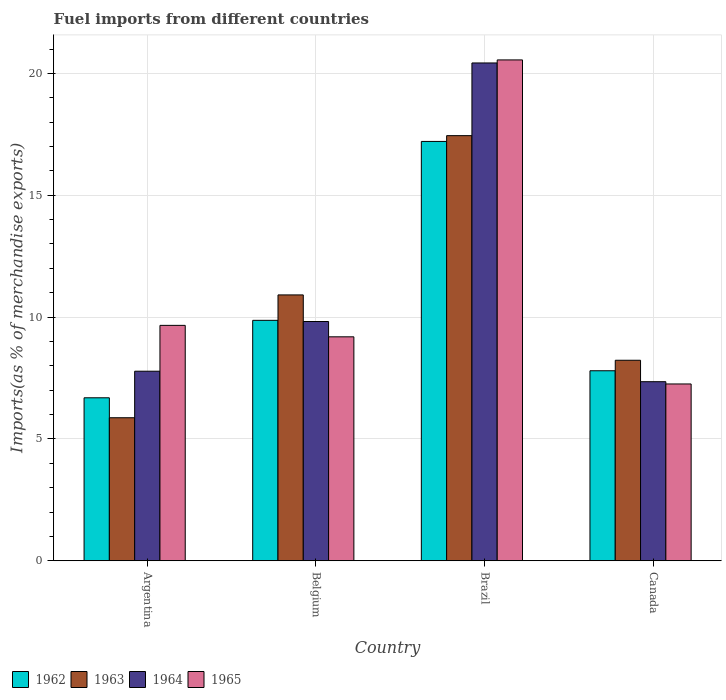How many different coloured bars are there?
Offer a terse response. 4. How many groups of bars are there?
Offer a very short reply. 4. Are the number of bars per tick equal to the number of legend labels?
Make the answer very short. Yes. Are the number of bars on each tick of the X-axis equal?
Give a very brief answer. Yes. How many bars are there on the 3rd tick from the left?
Ensure brevity in your answer.  4. What is the label of the 2nd group of bars from the left?
Your answer should be compact. Belgium. What is the percentage of imports to different countries in 1962 in Brazil?
Keep it short and to the point. 17.21. Across all countries, what is the maximum percentage of imports to different countries in 1965?
Your answer should be very brief. 20.55. Across all countries, what is the minimum percentage of imports to different countries in 1965?
Give a very brief answer. 7.26. In which country was the percentage of imports to different countries in 1964 maximum?
Ensure brevity in your answer.  Brazil. What is the total percentage of imports to different countries in 1963 in the graph?
Ensure brevity in your answer.  42.46. What is the difference between the percentage of imports to different countries in 1964 in Argentina and that in Brazil?
Your response must be concise. -12.65. What is the difference between the percentage of imports to different countries in 1964 in Canada and the percentage of imports to different countries in 1962 in Belgium?
Make the answer very short. -2.52. What is the average percentage of imports to different countries in 1964 per country?
Keep it short and to the point. 11.34. What is the difference between the percentage of imports to different countries of/in 1964 and percentage of imports to different countries of/in 1965 in Brazil?
Keep it short and to the point. -0.12. What is the ratio of the percentage of imports to different countries in 1962 in Argentina to that in Belgium?
Your response must be concise. 0.68. What is the difference between the highest and the second highest percentage of imports to different countries in 1962?
Your answer should be very brief. 7.34. What is the difference between the highest and the lowest percentage of imports to different countries in 1963?
Give a very brief answer. 11.58. Is it the case that in every country, the sum of the percentage of imports to different countries in 1965 and percentage of imports to different countries in 1962 is greater than the sum of percentage of imports to different countries in 1963 and percentage of imports to different countries in 1964?
Your response must be concise. No. What does the 1st bar from the right in Belgium represents?
Offer a very short reply. 1965. Is it the case that in every country, the sum of the percentage of imports to different countries in 1965 and percentage of imports to different countries in 1963 is greater than the percentage of imports to different countries in 1962?
Provide a short and direct response. Yes. What is the difference between two consecutive major ticks on the Y-axis?
Provide a short and direct response. 5. Does the graph contain grids?
Make the answer very short. Yes. How many legend labels are there?
Provide a succinct answer. 4. How are the legend labels stacked?
Your response must be concise. Horizontal. What is the title of the graph?
Your response must be concise. Fuel imports from different countries. What is the label or title of the X-axis?
Provide a succinct answer. Country. What is the label or title of the Y-axis?
Offer a terse response. Imports(as % of merchandise exports). What is the Imports(as % of merchandise exports) of 1962 in Argentina?
Offer a very short reply. 6.69. What is the Imports(as % of merchandise exports) in 1963 in Argentina?
Your response must be concise. 5.87. What is the Imports(as % of merchandise exports) of 1964 in Argentina?
Provide a short and direct response. 7.78. What is the Imports(as % of merchandise exports) in 1965 in Argentina?
Provide a short and direct response. 9.66. What is the Imports(as % of merchandise exports) in 1962 in Belgium?
Ensure brevity in your answer.  9.87. What is the Imports(as % of merchandise exports) of 1963 in Belgium?
Give a very brief answer. 10.91. What is the Imports(as % of merchandise exports) of 1964 in Belgium?
Your answer should be compact. 9.82. What is the Imports(as % of merchandise exports) of 1965 in Belgium?
Provide a succinct answer. 9.19. What is the Imports(as % of merchandise exports) in 1962 in Brazil?
Offer a terse response. 17.21. What is the Imports(as % of merchandise exports) in 1963 in Brazil?
Give a very brief answer. 17.45. What is the Imports(as % of merchandise exports) in 1964 in Brazil?
Provide a succinct answer. 20.43. What is the Imports(as % of merchandise exports) in 1965 in Brazil?
Offer a terse response. 20.55. What is the Imports(as % of merchandise exports) in 1962 in Canada?
Your answer should be very brief. 7.8. What is the Imports(as % of merchandise exports) in 1963 in Canada?
Offer a terse response. 8.23. What is the Imports(as % of merchandise exports) in 1964 in Canada?
Your answer should be compact. 7.35. What is the Imports(as % of merchandise exports) of 1965 in Canada?
Keep it short and to the point. 7.26. Across all countries, what is the maximum Imports(as % of merchandise exports) of 1962?
Make the answer very short. 17.21. Across all countries, what is the maximum Imports(as % of merchandise exports) of 1963?
Provide a succinct answer. 17.45. Across all countries, what is the maximum Imports(as % of merchandise exports) in 1964?
Ensure brevity in your answer.  20.43. Across all countries, what is the maximum Imports(as % of merchandise exports) in 1965?
Keep it short and to the point. 20.55. Across all countries, what is the minimum Imports(as % of merchandise exports) in 1962?
Provide a short and direct response. 6.69. Across all countries, what is the minimum Imports(as % of merchandise exports) of 1963?
Offer a terse response. 5.87. Across all countries, what is the minimum Imports(as % of merchandise exports) in 1964?
Offer a terse response. 7.35. Across all countries, what is the minimum Imports(as % of merchandise exports) in 1965?
Make the answer very short. 7.26. What is the total Imports(as % of merchandise exports) in 1962 in the graph?
Offer a terse response. 41.56. What is the total Imports(as % of merchandise exports) of 1963 in the graph?
Offer a terse response. 42.46. What is the total Imports(as % of merchandise exports) of 1964 in the graph?
Ensure brevity in your answer.  45.38. What is the total Imports(as % of merchandise exports) in 1965 in the graph?
Offer a very short reply. 46.66. What is the difference between the Imports(as % of merchandise exports) in 1962 in Argentina and that in Belgium?
Your answer should be compact. -3.18. What is the difference between the Imports(as % of merchandise exports) in 1963 in Argentina and that in Belgium?
Your response must be concise. -5.04. What is the difference between the Imports(as % of merchandise exports) in 1964 in Argentina and that in Belgium?
Your answer should be compact. -2.04. What is the difference between the Imports(as % of merchandise exports) of 1965 in Argentina and that in Belgium?
Offer a terse response. 0.47. What is the difference between the Imports(as % of merchandise exports) of 1962 in Argentina and that in Brazil?
Your response must be concise. -10.52. What is the difference between the Imports(as % of merchandise exports) of 1963 in Argentina and that in Brazil?
Your answer should be compact. -11.58. What is the difference between the Imports(as % of merchandise exports) in 1964 in Argentina and that in Brazil?
Offer a terse response. -12.65. What is the difference between the Imports(as % of merchandise exports) in 1965 in Argentina and that in Brazil?
Provide a short and direct response. -10.89. What is the difference between the Imports(as % of merchandise exports) of 1962 in Argentina and that in Canada?
Offer a very short reply. -1.11. What is the difference between the Imports(as % of merchandise exports) in 1963 in Argentina and that in Canada?
Your response must be concise. -2.36. What is the difference between the Imports(as % of merchandise exports) of 1964 in Argentina and that in Canada?
Your response must be concise. 0.43. What is the difference between the Imports(as % of merchandise exports) of 1965 in Argentina and that in Canada?
Offer a very short reply. 2.4. What is the difference between the Imports(as % of merchandise exports) of 1962 in Belgium and that in Brazil?
Your response must be concise. -7.34. What is the difference between the Imports(as % of merchandise exports) in 1963 in Belgium and that in Brazil?
Offer a very short reply. -6.54. What is the difference between the Imports(as % of merchandise exports) in 1964 in Belgium and that in Brazil?
Give a very brief answer. -10.61. What is the difference between the Imports(as % of merchandise exports) of 1965 in Belgium and that in Brazil?
Keep it short and to the point. -11.36. What is the difference between the Imports(as % of merchandise exports) in 1962 in Belgium and that in Canada?
Your answer should be very brief. 2.07. What is the difference between the Imports(as % of merchandise exports) in 1963 in Belgium and that in Canada?
Offer a terse response. 2.68. What is the difference between the Imports(as % of merchandise exports) in 1964 in Belgium and that in Canada?
Provide a succinct answer. 2.47. What is the difference between the Imports(as % of merchandise exports) in 1965 in Belgium and that in Canada?
Offer a very short reply. 1.93. What is the difference between the Imports(as % of merchandise exports) of 1962 in Brazil and that in Canada?
Ensure brevity in your answer.  9.41. What is the difference between the Imports(as % of merchandise exports) of 1963 in Brazil and that in Canada?
Give a very brief answer. 9.22. What is the difference between the Imports(as % of merchandise exports) of 1964 in Brazil and that in Canada?
Give a very brief answer. 13.08. What is the difference between the Imports(as % of merchandise exports) of 1965 in Brazil and that in Canada?
Offer a very short reply. 13.3. What is the difference between the Imports(as % of merchandise exports) of 1962 in Argentina and the Imports(as % of merchandise exports) of 1963 in Belgium?
Offer a very short reply. -4.22. What is the difference between the Imports(as % of merchandise exports) in 1962 in Argentina and the Imports(as % of merchandise exports) in 1964 in Belgium?
Your response must be concise. -3.13. What is the difference between the Imports(as % of merchandise exports) in 1962 in Argentina and the Imports(as % of merchandise exports) in 1965 in Belgium?
Provide a succinct answer. -2.5. What is the difference between the Imports(as % of merchandise exports) of 1963 in Argentina and the Imports(as % of merchandise exports) of 1964 in Belgium?
Keep it short and to the point. -3.95. What is the difference between the Imports(as % of merchandise exports) of 1963 in Argentina and the Imports(as % of merchandise exports) of 1965 in Belgium?
Your answer should be compact. -3.32. What is the difference between the Imports(as % of merchandise exports) in 1964 in Argentina and the Imports(as % of merchandise exports) in 1965 in Belgium?
Give a very brief answer. -1.41. What is the difference between the Imports(as % of merchandise exports) in 1962 in Argentina and the Imports(as % of merchandise exports) in 1963 in Brazil?
Provide a succinct answer. -10.76. What is the difference between the Imports(as % of merchandise exports) in 1962 in Argentina and the Imports(as % of merchandise exports) in 1964 in Brazil?
Offer a very short reply. -13.74. What is the difference between the Imports(as % of merchandise exports) in 1962 in Argentina and the Imports(as % of merchandise exports) in 1965 in Brazil?
Your response must be concise. -13.87. What is the difference between the Imports(as % of merchandise exports) in 1963 in Argentina and the Imports(as % of merchandise exports) in 1964 in Brazil?
Your answer should be compact. -14.56. What is the difference between the Imports(as % of merchandise exports) of 1963 in Argentina and the Imports(as % of merchandise exports) of 1965 in Brazil?
Your answer should be very brief. -14.68. What is the difference between the Imports(as % of merchandise exports) in 1964 in Argentina and the Imports(as % of merchandise exports) in 1965 in Brazil?
Make the answer very short. -12.77. What is the difference between the Imports(as % of merchandise exports) in 1962 in Argentina and the Imports(as % of merchandise exports) in 1963 in Canada?
Make the answer very short. -1.54. What is the difference between the Imports(as % of merchandise exports) in 1962 in Argentina and the Imports(as % of merchandise exports) in 1964 in Canada?
Provide a short and direct response. -0.66. What is the difference between the Imports(as % of merchandise exports) of 1962 in Argentina and the Imports(as % of merchandise exports) of 1965 in Canada?
Offer a terse response. -0.57. What is the difference between the Imports(as % of merchandise exports) in 1963 in Argentina and the Imports(as % of merchandise exports) in 1964 in Canada?
Give a very brief answer. -1.48. What is the difference between the Imports(as % of merchandise exports) in 1963 in Argentina and the Imports(as % of merchandise exports) in 1965 in Canada?
Provide a short and direct response. -1.39. What is the difference between the Imports(as % of merchandise exports) in 1964 in Argentina and the Imports(as % of merchandise exports) in 1965 in Canada?
Offer a terse response. 0.52. What is the difference between the Imports(as % of merchandise exports) in 1962 in Belgium and the Imports(as % of merchandise exports) in 1963 in Brazil?
Offer a terse response. -7.58. What is the difference between the Imports(as % of merchandise exports) in 1962 in Belgium and the Imports(as % of merchandise exports) in 1964 in Brazil?
Provide a succinct answer. -10.56. What is the difference between the Imports(as % of merchandise exports) of 1962 in Belgium and the Imports(as % of merchandise exports) of 1965 in Brazil?
Keep it short and to the point. -10.69. What is the difference between the Imports(as % of merchandise exports) in 1963 in Belgium and the Imports(as % of merchandise exports) in 1964 in Brazil?
Ensure brevity in your answer.  -9.52. What is the difference between the Imports(as % of merchandise exports) in 1963 in Belgium and the Imports(as % of merchandise exports) in 1965 in Brazil?
Your answer should be very brief. -9.64. What is the difference between the Imports(as % of merchandise exports) of 1964 in Belgium and the Imports(as % of merchandise exports) of 1965 in Brazil?
Keep it short and to the point. -10.74. What is the difference between the Imports(as % of merchandise exports) of 1962 in Belgium and the Imports(as % of merchandise exports) of 1963 in Canada?
Make the answer very short. 1.64. What is the difference between the Imports(as % of merchandise exports) of 1962 in Belgium and the Imports(as % of merchandise exports) of 1964 in Canada?
Offer a very short reply. 2.52. What is the difference between the Imports(as % of merchandise exports) of 1962 in Belgium and the Imports(as % of merchandise exports) of 1965 in Canada?
Your answer should be very brief. 2.61. What is the difference between the Imports(as % of merchandise exports) in 1963 in Belgium and the Imports(as % of merchandise exports) in 1964 in Canada?
Ensure brevity in your answer.  3.56. What is the difference between the Imports(as % of merchandise exports) of 1963 in Belgium and the Imports(as % of merchandise exports) of 1965 in Canada?
Your answer should be compact. 3.65. What is the difference between the Imports(as % of merchandise exports) in 1964 in Belgium and the Imports(as % of merchandise exports) in 1965 in Canada?
Give a very brief answer. 2.56. What is the difference between the Imports(as % of merchandise exports) in 1962 in Brazil and the Imports(as % of merchandise exports) in 1963 in Canada?
Your response must be concise. 8.98. What is the difference between the Imports(as % of merchandise exports) in 1962 in Brazil and the Imports(as % of merchandise exports) in 1964 in Canada?
Provide a short and direct response. 9.86. What is the difference between the Imports(as % of merchandise exports) of 1962 in Brazil and the Imports(as % of merchandise exports) of 1965 in Canada?
Provide a succinct answer. 9.95. What is the difference between the Imports(as % of merchandise exports) of 1963 in Brazil and the Imports(as % of merchandise exports) of 1964 in Canada?
Provide a succinct answer. 10.1. What is the difference between the Imports(as % of merchandise exports) of 1963 in Brazil and the Imports(as % of merchandise exports) of 1965 in Canada?
Your response must be concise. 10.19. What is the difference between the Imports(as % of merchandise exports) in 1964 in Brazil and the Imports(as % of merchandise exports) in 1965 in Canada?
Make the answer very short. 13.17. What is the average Imports(as % of merchandise exports) in 1962 per country?
Keep it short and to the point. 10.39. What is the average Imports(as % of merchandise exports) in 1963 per country?
Make the answer very short. 10.61. What is the average Imports(as % of merchandise exports) of 1964 per country?
Give a very brief answer. 11.34. What is the average Imports(as % of merchandise exports) of 1965 per country?
Offer a very short reply. 11.67. What is the difference between the Imports(as % of merchandise exports) of 1962 and Imports(as % of merchandise exports) of 1963 in Argentina?
Offer a terse response. 0.82. What is the difference between the Imports(as % of merchandise exports) of 1962 and Imports(as % of merchandise exports) of 1964 in Argentina?
Make the answer very short. -1.09. What is the difference between the Imports(as % of merchandise exports) in 1962 and Imports(as % of merchandise exports) in 1965 in Argentina?
Make the answer very short. -2.97. What is the difference between the Imports(as % of merchandise exports) of 1963 and Imports(as % of merchandise exports) of 1964 in Argentina?
Keep it short and to the point. -1.91. What is the difference between the Imports(as % of merchandise exports) in 1963 and Imports(as % of merchandise exports) in 1965 in Argentina?
Keep it short and to the point. -3.79. What is the difference between the Imports(as % of merchandise exports) in 1964 and Imports(as % of merchandise exports) in 1965 in Argentina?
Offer a terse response. -1.88. What is the difference between the Imports(as % of merchandise exports) in 1962 and Imports(as % of merchandise exports) in 1963 in Belgium?
Provide a short and direct response. -1.04. What is the difference between the Imports(as % of merchandise exports) in 1962 and Imports(as % of merchandise exports) in 1964 in Belgium?
Make the answer very short. 0.05. What is the difference between the Imports(as % of merchandise exports) of 1962 and Imports(as % of merchandise exports) of 1965 in Belgium?
Your response must be concise. 0.68. What is the difference between the Imports(as % of merchandise exports) in 1963 and Imports(as % of merchandise exports) in 1964 in Belgium?
Your response must be concise. 1.09. What is the difference between the Imports(as % of merchandise exports) of 1963 and Imports(as % of merchandise exports) of 1965 in Belgium?
Provide a short and direct response. 1.72. What is the difference between the Imports(as % of merchandise exports) of 1964 and Imports(as % of merchandise exports) of 1965 in Belgium?
Offer a terse response. 0.63. What is the difference between the Imports(as % of merchandise exports) of 1962 and Imports(as % of merchandise exports) of 1963 in Brazil?
Offer a very short reply. -0.24. What is the difference between the Imports(as % of merchandise exports) of 1962 and Imports(as % of merchandise exports) of 1964 in Brazil?
Offer a very short reply. -3.22. What is the difference between the Imports(as % of merchandise exports) of 1962 and Imports(as % of merchandise exports) of 1965 in Brazil?
Provide a succinct answer. -3.35. What is the difference between the Imports(as % of merchandise exports) in 1963 and Imports(as % of merchandise exports) in 1964 in Brazil?
Your response must be concise. -2.98. What is the difference between the Imports(as % of merchandise exports) of 1963 and Imports(as % of merchandise exports) of 1965 in Brazil?
Keep it short and to the point. -3.11. What is the difference between the Imports(as % of merchandise exports) in 1964 and Imports(as % of merchandise exports) in 1965 in Brazil?
Give a very brief answer. -0.12. What is the difference between the Imports(as % of merchandise exports) in 1962 and Imports(as % of merchandise exports) in 1963 in Canada?
Provide a succinct answer. -0.43. What is the difference between the Imports(as % of merchandise exports) in 1962 and Imports(as % of merchandise exports) in 1964 in Canada?
Keep it short and to the point. 0.45. What is the difference between the Imports(as % of merchandise exports) in 1962 and Imports(as % of merchandise exports) in 1965 in Canada?
Your response must be concise. 0.54. What is the difference between the Imports(as % of merchandise exports) in 1963 and Imports(as % of merchandise exports) in 1964 in Canada?
Keep it short and to the point. 0.88. What is the difference between the Imports(as % of merchandise exports) in 1963 and Imports(as % of merchandise exports) in 1965 in Canada?
Make the answer very short. 0.97. What is the difference between the Imports(as % of merchandise exports) of 1964 and Imports(as % of merchandise exports) of 1965 in Canada?
Ensure brevity in your answer.  0.09. What is the ratio of the Imports(as % of merchandise exports) in 1962 in Argentina to that in Belgium?
Provide a short and direct response. 0.68. What is the ratio of the Imports(as % of merchandise exports) in 1963 in Argentina to that in Belgium?
Provide a short and direct response. 0.54. What is the ratio of the Imports(as % of merchandise exports) of 1964 in Argentina to that in Belgium?
Your answer should be very brief. 0.79. What is the ratio of the Imports(as % of merchandise exports) in 1965 in Argentina to that in Belgium?
Provide a short and direct response. 1.05. What is the ratio of the Imports(as % of merchandise exports) of 1962 in Argentina to that in Brazil?
Give a very brief answer. 0.39. What is the ratio of the Imports(as % of merchandise exports) of 1963 in Argentina to that in Brazil?
Your answer should be compact. 0.34. What is the ratio of the Imports(as % of merchandise exports) of 1964 in Argentina to that in Brazil?
Your answer should be compact. 0.38. What is the ratio of the Imports(as % of merchandise exports) of 1965 in Argentina to that in Brazil?
Make the answer very short. 0.47. What is the ratio of the Imports(as % of merchandise exports) in 1962 in Argentina to that in Canada?
Ensure brevity in your answer.  0.86. What is the ratio of the Imports(as % of merchandise exports) in 1963 in Argentina to that in Canada?
Make the answer very short. 0.71. What is the ratio of the Imports(as % of merchandise exports) of 1964 in Argentina to that in Canada?
Keep it short and to the point. 1.06. What is the ratio of the Imports(as % of merchandise exports) of 1965 in Argentina to that in Canada?
Your answer should be very brief. 1.33. What is the ratio of the Imports(as % of merchandise exports) of 1962 in Belgium to that in Brazil?
Keep it short and to the point. 0.57. What is the ratio of the Imports(as % of merchandise exports) of 1963 in Belgium to that in Brazil?
Your response must be concise. 0.63. What is the ratio of the Imports(as % of merchandise exports) of 1964 in Belgium to that in Brazil?
Your answer should be compact. 0.48. What is the ratio of the Imports(as % of merchandise exports) in 1965 in Belgium to that in Brazil?
Provide a succinct answer. 0.45. What is the ratio of the Imports(as % of merchandise exports) of 1962 in Belgium to that in Canada?
Your answer should be very brief. 1.27. What is the ratio of the Imports(as % of merchandise exports) in 1963 in Belgium to that in Canada?
Offer a terse response. 1.33. What is the ratio of the Imports(as % of merchandise exports) in 1964 in Belgium to that in Canada?
Offer a terse response. 1.34. What is the ratio of the Imports(as % of merchandise exports) in 1965 in Belgium to that in Canada?
Ensure brevity in your answer.  1.27. What is the ratio of the Imports(as % of merchandise exports) in 1962 in Brazil to that in Canada?
Keep it short and to the point. 2.21. What is the ratio of the Imports(as % of merchandise exports) of 1963 in Brazil to that in Canada?
Your response must be concise. 2.12. What is the ratio of the Imports(as % of merchandise exports) of 1964 in Brazil to that in Canada?
Your answer should be very brief. 2.78. What is the ratio of the Imports(as % of merchandise exports) in 1965 in Brazil to that in Canada?
Make the answer very short. 2.83. What is the difference between the highest and the second highest Imports(as % of merchandise exports) of 1962?
Offer a terse response. 7.34. What is the difference between the highest and the second highest Imports(as % of merchandise exports) of 1963?
Give a very brief answer. 6.54. What is the difference between the highest and the second highest Imports(as % of merchandise exports) of 1964?
Keep it short and to the point. 10.61. What is the difference between the highest and the second highest Imports(as % of merchandise exports) in 1965?
Ensure brevity in your answer.  10.89. What is the difference between the highest and the lowest Imports(as % of merchandise exports) in 1962?
Ensure brevity in your answer.  10.52. What is the difference between the highest and the lowest Imports(as % of merchandise exports) of 1963?
Your answer should be very brief. 11.58. What is the difference between the highest and the lowest Imports(as % of merchandise exports) in 1964?
Keep it short and to the point. 13.08. What is the difference between the highest and the lowest Imports(as % of merchandise exports) in 1965?
Provide a succinct answer. 13.3. 